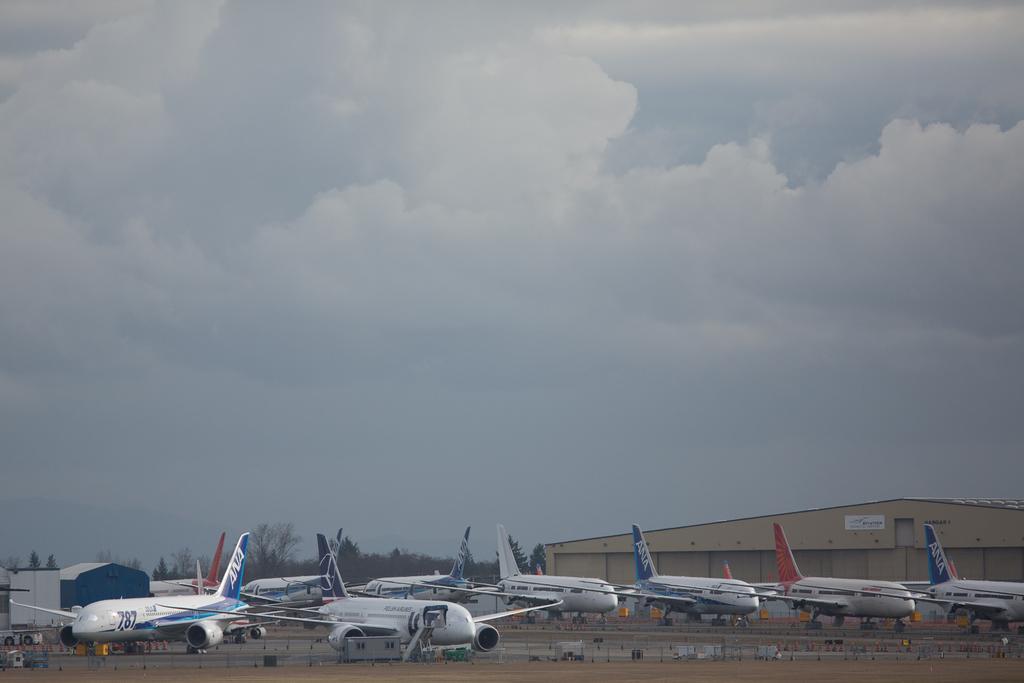Please provide a concise description of this image. The picture is clicked in an airport. In the foreground of the picture there are airplanes, runway, buildings, trees, poles and other objects. Sky is cloudy. 